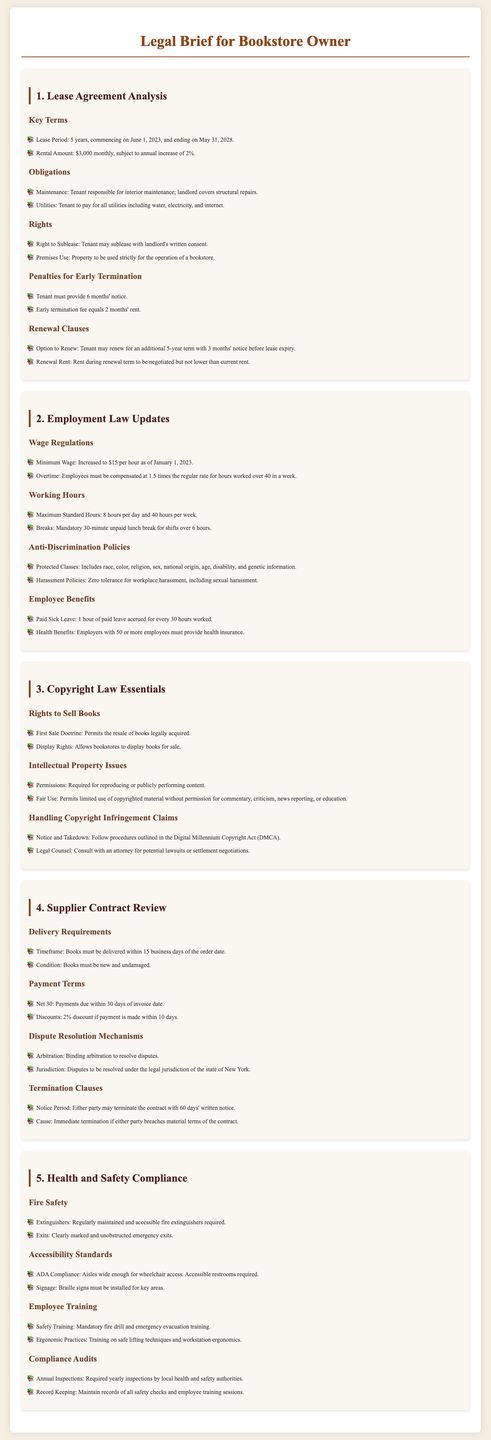what is the lease period for the bookstore? The lease period starts on June 1, 2023, and ends on May 31, 2028, which is a duration of 5 years.
Answer: 5 years what is the monthly rental amount? The document states that the rental amount is $3,000 monthly.
Answer: $3,000 what is the minimum wage increase effective date? The minimum wage increase to $15 per hour became effective on January 1, 2023.
Answer: January 1, 2023 how many hours of paid sick leave are accrued for every 30 hours worked? The document specifies that 1 hour of paid sick leave is accrued for every 30 hours worked.
Answer: 1 hour what mechanism is used for dispute resolution in supplier contracts? The supplier contracts specify that binding arbitration is the mechanism used to resolve disputes.
Answer: Binding arbitration what must be provided for early termination of the lease? The tenant must provide 6 months' notice for early termination of the lease.
Answer: 6 months' notice what does the First Sale Doctrine permit? The First Sale Doctrine permits the resale of books that have been legally acquired.
Answer: Resale of books how often are compliance audits required? The document states that annual inspections are required by local health and safety authorities.
Answer: Annual inspections what is the notice period for terminating the supplier contract? Either party may terminate the contract with 60 days' written notice.
Answer: 60 days' written notice 